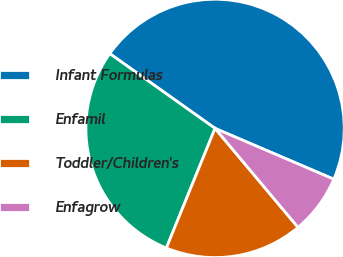<chart> <loc_0><loc_0><loc_500><loc_500><pie_chart><fcel>Infant Formulas<fcel>Enfamil<fcel>Toddler/Children's<fcel>Enfagrow<nl><fcel>46.61%<fcel>28.67%<fcel>17.26%<fcel>7.46%<nl></chart> 